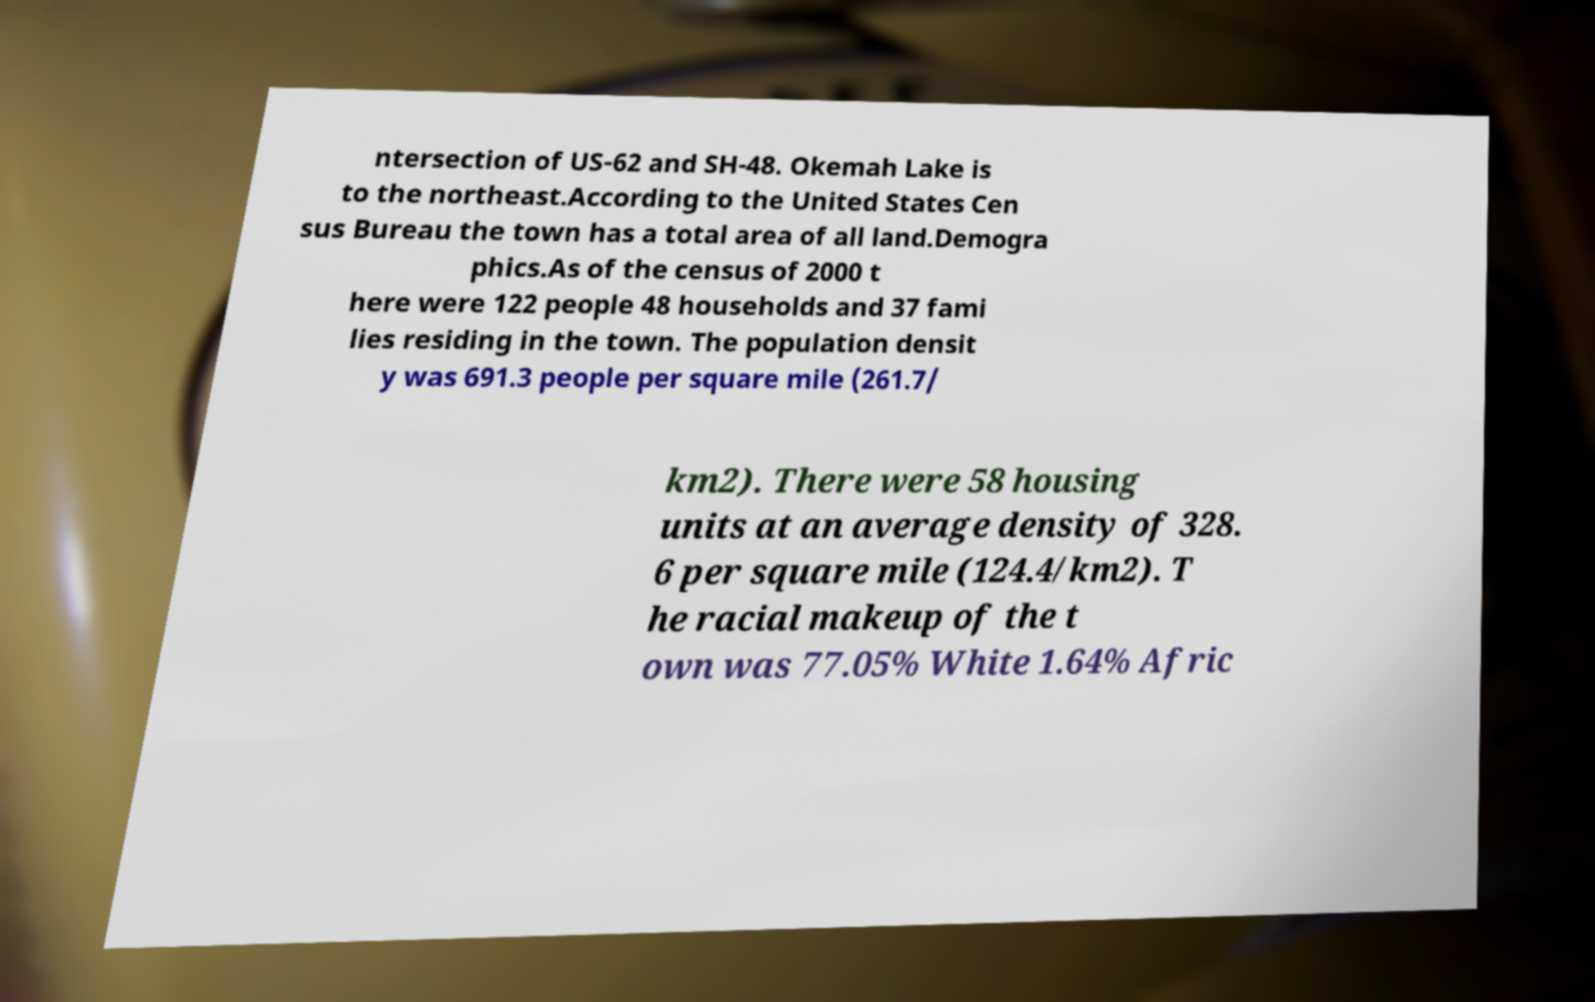Can you read and provide the text displayed in the image?This photo seems to have some interesting text. Can you extract and type it out for me? ntersection of US-62 and SH-48. Okemah Lake is to the northeast.According to the United States Cen sus Bureau the town has a total area of all land.Demogra phics.As of the census of 2000 t here were 122 people 48 households and 37 fami lies residing in the town. The population densit y was 691.3 people per square mile (261.7/ km2). There were 58 housing units at an average density of 328. 6 per square mile (124.4/km2). T he racial makeup of the t own was 77.05% White 1.64% Afric 